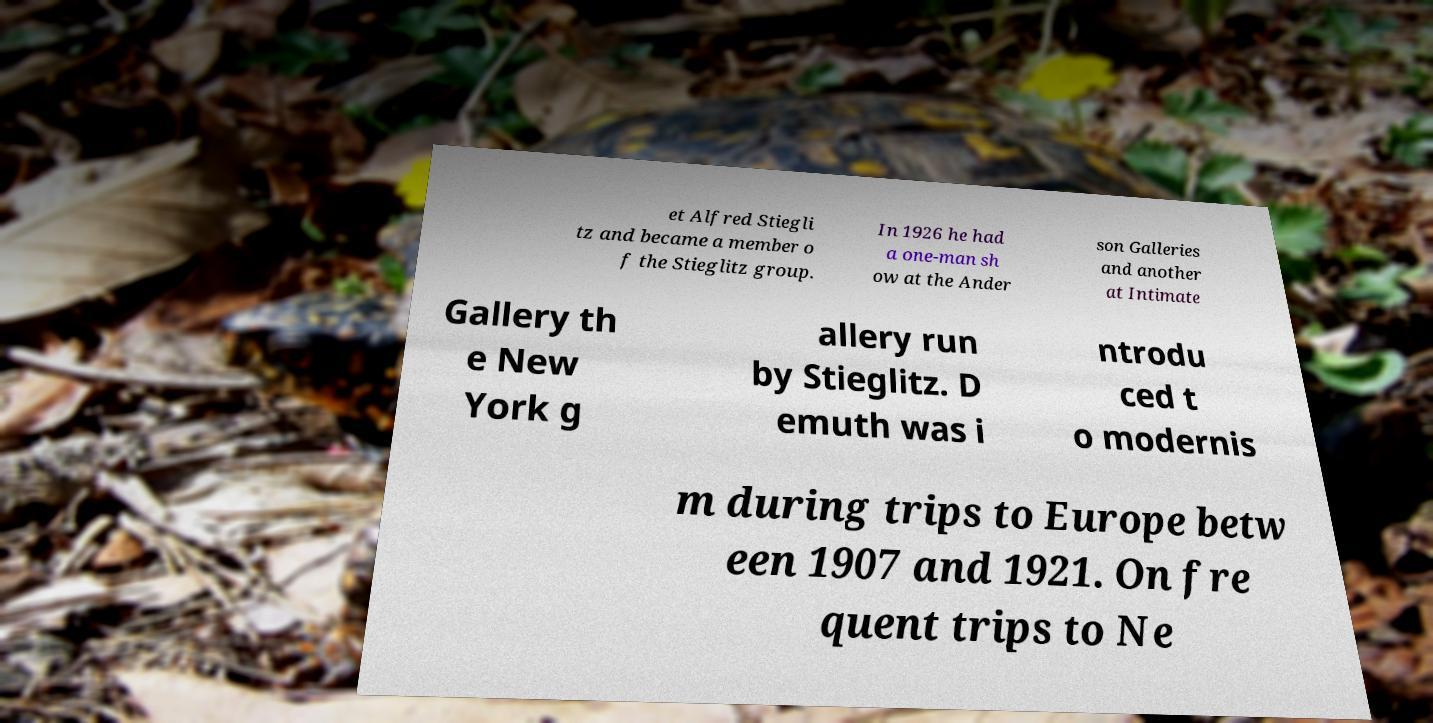Could you assist in decoding the text presented in this image and type it out clearly? et Alfred Stiegli tz and became a member o f the Stieglitz group. In 1926 he had a one-man sh ow at the Ander son Galleries and another at Intimate Gallery th e New York g allery run by Stieglitz. D emuth was i ntrodu ced t o modernis m during trips to Europe betw een 1907 and 1921. On fre quent trips to Ne 